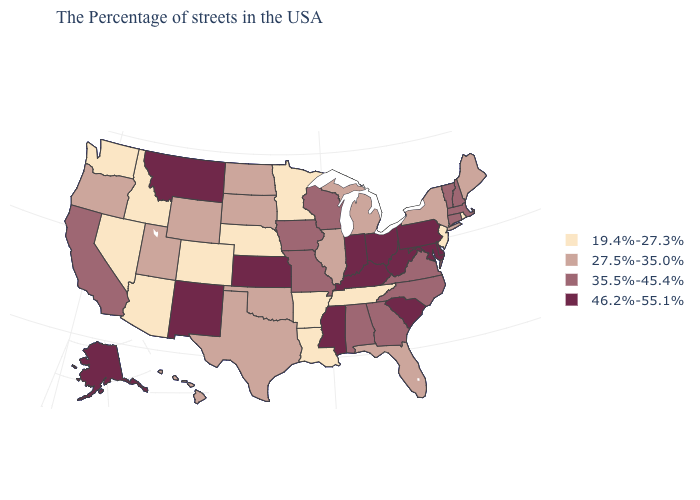What is the value of New York?
Answer briefly. 27.5%-35.0%. What is the value of Kentucky?
Be succinct. 46.2%-55.1%. What is the value of Minnesota?
Keep it brief. 19.4%-27.3%. Which states have the lowest value in the USA?
Give a very brief answer. Rhode Island, New Jersey, Tennessee, Louisiana, Arkansas, Minnesota, Nebraska, Colorado, Arizona, Idaho, Nevada, Washington. What is the value of Tennessee?
Short answer required. 19.4%-27.3%. What is the lowest value in the South?
Write a very short answer. 19.4%-27.3%. Name the states that have a value in the range 46.2%-55.1%?
Be succinct. Delaware, Maryland, Pennsylvania, South Carolina, West Virginia, Ohio, Kentucky, Indiana, Mississippi, Kansas, New Mexico, Montana, Alaska. What is the lowest value in states that border Minnesota?
Answer briefly. 27.5%-35.0%. What is the highest value in the USA?
Keep it brief. 46.2%-55.1%. Which states hav the highest value in the Northeast?
Quick response, please. Pennsylvania. Does Idaho have the lowest value in the USA?
Answer briefly. Yes. What is the value of Idaho?
Write a very short answer. 19.4%-27.3%. Name the states that have a value in the range 19.4%-27.3%?
Be succinct. Rhode Island, New Jersey, Tennessee, Louisiana, Arkansas, Minnesota, Nebraska, Colorado, Arizona, Idaho, Nevada, Washington. Does Montana have the same value as South Carolina?
Quick response, please. Yes. Among the states that border Arkansas , which have the lowest value?
Answer briefly. Tennessee, Louisiana. 